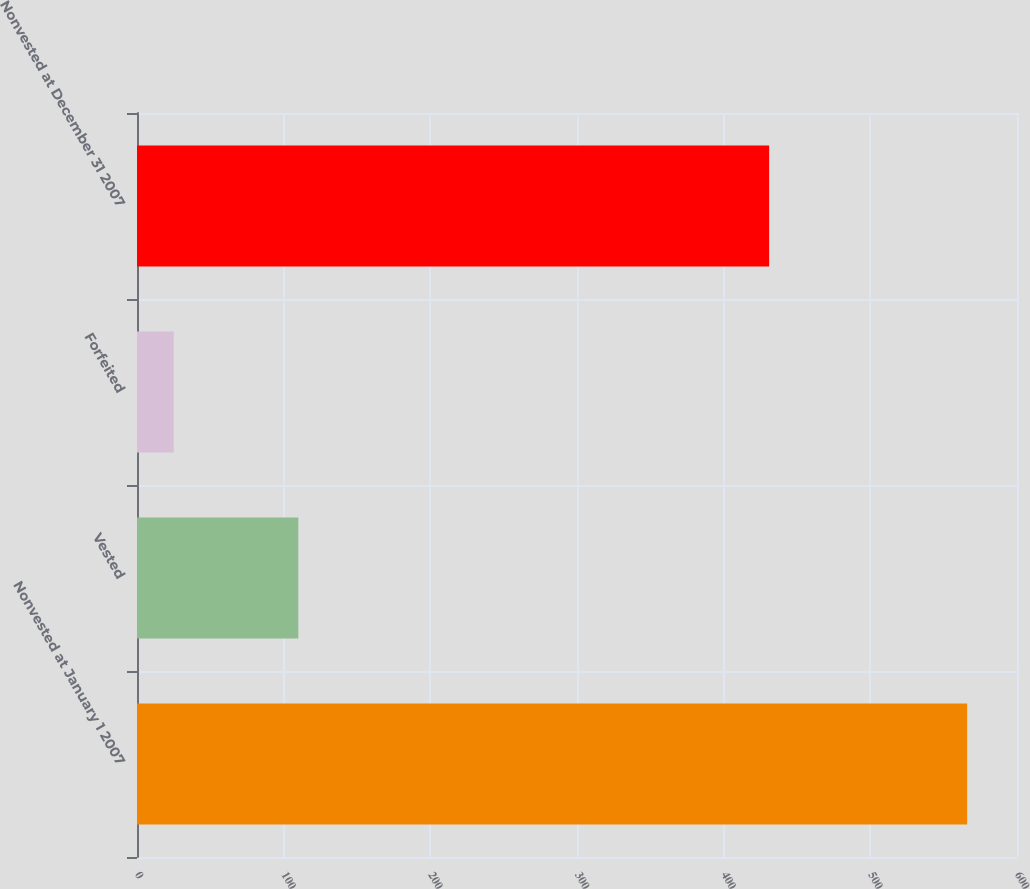Convert chart. <chart><loc_0><loc_0><loc_500><loc_500><bar_chart><fcel>Nonvested at January 1 2007<fcel>Vested<fcel>Forfeited<fcel>Nonvested at December 31 2007<nl><fcel>566<fcel>110<fcel>25<fcel>431<nl></chart> 